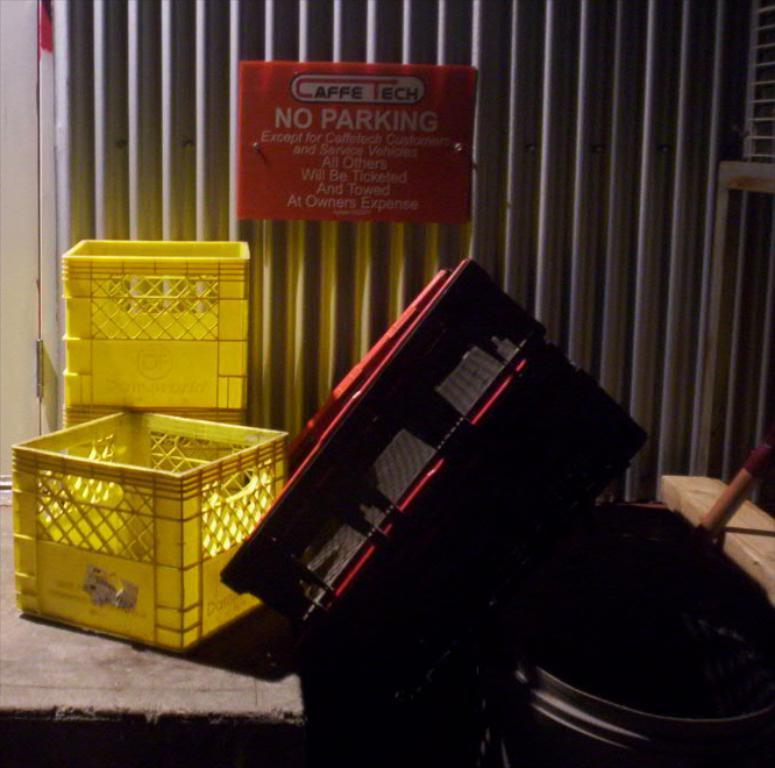In one or two sentences, can you explain what this image depicts? In this image I see 2 yellow color trays and few things over here and I see a red color board on which something is written. 